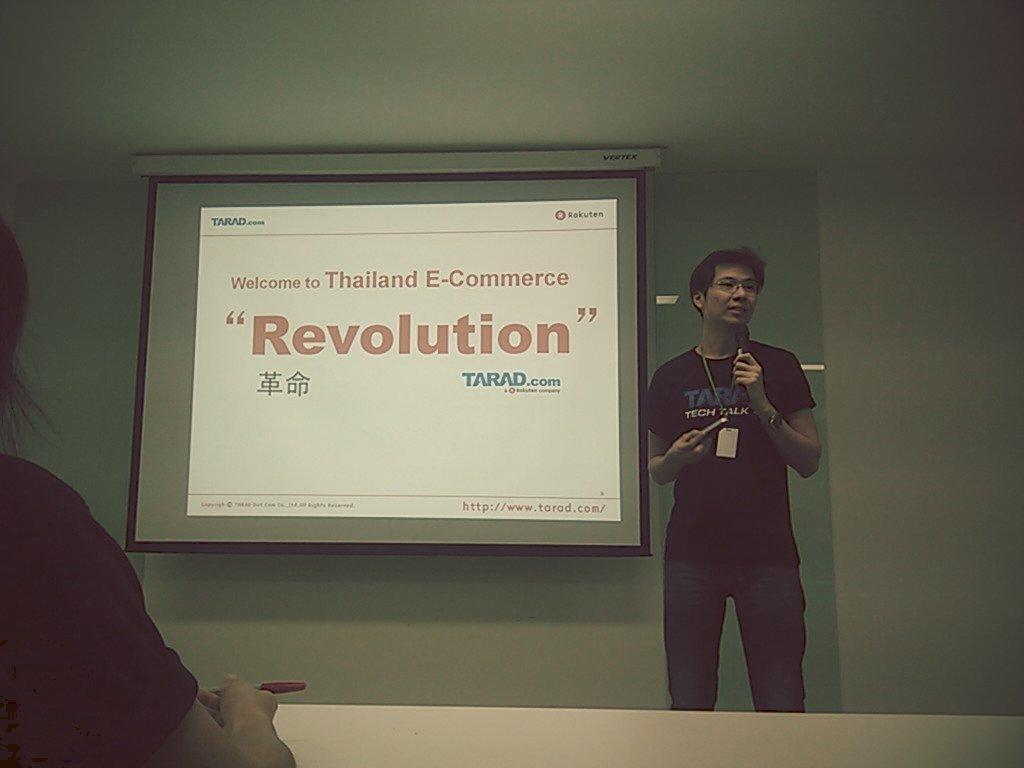How would you summarize this image in a sentence or two? In this picture there is a man standing and holding the microphone and he is talking. At the back there is a screen and there is text on the screen. In the foreground there is a person sitting and holding the pen. 